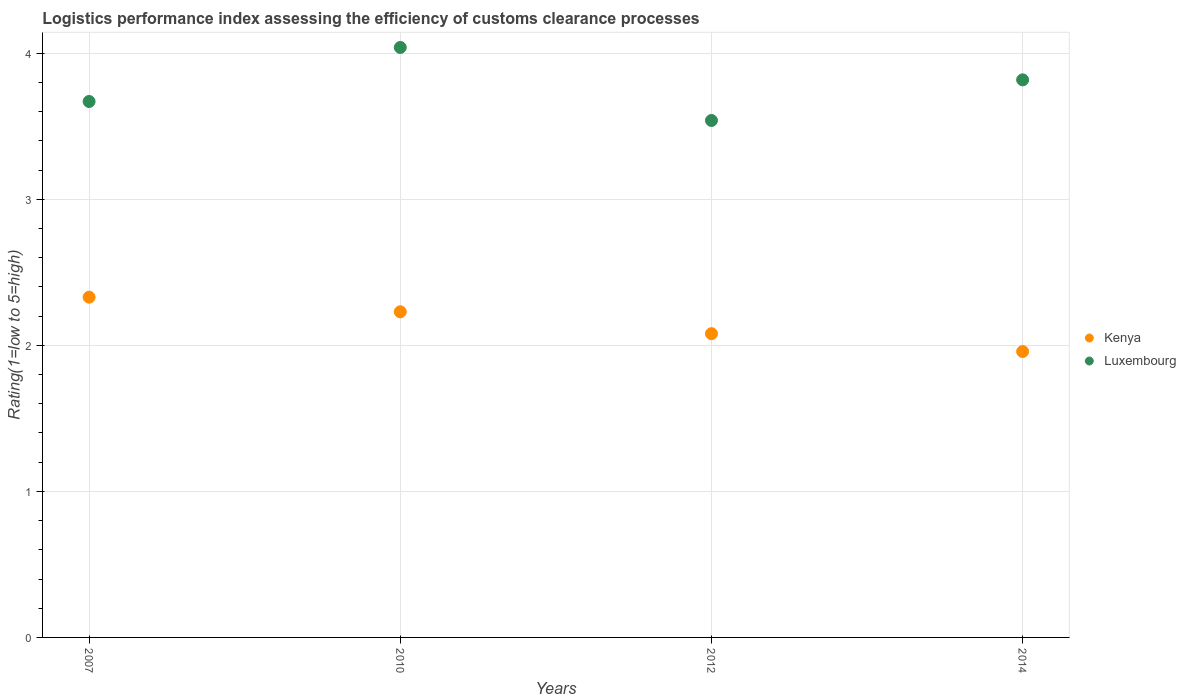What is the Logistic performance index in Kenya in 2007?
Provide a short and direct response. 2.33. Across all years, what is the maximum Logistic performance index in Luxembourg?
Keep it short and to the point. 4.04. Across all years, what is the minimum Logistic performance index in Luxembourg?
Provide a short and direct response. 3.54. In which year was the Logistic performance index in Luxembourg minimum?
Your response must be concise. 2012. What is the total Logistic performance index in Kenya in the graph?
Give a very brief answer. 8.6. What is the difference between the Logistic performance index in Kenya in 2012 and that in 2014?
Your answer should be very brief. 0.12. What is the difference between the Logistic performance index in Luxembourg in 2007 and the Logistic performance index in Kenya in 2010?
Offer a terse response. 1.44. What is the average Logistic performance index in Kenya per year?
Make the answer very short. 2.15. In the year 2012, what is the difference between the Logistic performance index in Kenya and Logistic performance index in Luxembourg?
Give a very brief answer. -1.46. What is the ratio of the Logistic performance index in Luxembourg in 2007 to that in 2014?
Give a very brief answer. 0.96. What is the difference between the highest and the second highest Logistic performance index in Luxembourg?
Keep it short and to the point. 0.22. What is the difference between the highest and the lowest Logistic performance index in Luxembourg?
Keep it short and to the point. 0.5. In how many years, is the Logistic performance index in Luxembourg greater than the average Logistic performance index in Luxembourg taken over all years?
Offer a very short reply. 2. Is the Logistic performance index in Luxembourg strictly less than the Logistic performance index in Kenya over the years?
Give a very brief answer. No. How many dotlines are there?
Offer a terse response. 2. How many years are there in the graph?
Your answer should be very brief. 4. What is the difference between two consecutive major ticks on the Y-axis?
Make the answer very short. 1. Are the values on the major ticks of Y-axis written in scientific E-notation?
Offer a terse response. No. Does the graph contain any zero values?
Offer a terse response. No. Does the graph contain grids?
Offer a very short reply. Yes. Where does the legend appear in the graph?
Provide a succinct answer. Center right. How many legend labels are there?
Ensure brevity in your answer.  2. What is the title of the graph?
Your answer should be very brief. Logistics performance index assessing the efficiency of customs clearance processes. What is the label or title of the X-axis?
Your answer should be compact. Years. What is the label or title of the Y-axis?
Offer a terse response. Rating(1=low to 5=high). What is the Rating(1=low to 5=high) of Kenya in 2007?
Offer a terse response. 2.33. What is the Rating(1=low to 5=high) of Luxembourg in 2007?
Provide a short and direct response. 3.67. What is the Rating(1=low to 5=high) in Kenya in 2010?
Provide a succinct answer. 2.23. What is the Rating(1=low to 5=high) in Luxembourg in 2010?
Make the answer very short. 4.04. What is the Rating(1=low to 5=high) in Kenya in 2012?
Provide a short and direct response. 2.08. What is the Rating(1=low to 5=high) of Luxembourg in 2012?
Keep it short and to the point. 3.54. What is the Rating(1=low to 5=high) in Kenya in 2014?
Make the answer very short. 1.96. What is the Rating(1=low to 5=high) of Luxembourg in 2014?
Give a very brief answer. 3.82. Across all years, what is the maximum Rating(1=low to 5=high) of Kenya?
Your response must be concise. 2.33. Across all years, what is the maximum Rating(1=low to 5=high) of Luxembourg?
Your response must be concise. 4.04. Across all years, what is the minimum Rating(1=low to 5=high) of Kenya?
Ensure brevity in your answer.  1.96. Across all years, what is the minimum Rating(1=low to 5=high) in Luxembourg?
Your answer should be very brief. 3.54. What is the total Rating(1=low to 5=high) in Kenya in the graph?
Your answer should be very brief. 8.6. What is the total Rating(1=low to 5=high) of Luxembourg in the graph?
Make the answer very short. 15.07. What is the difference between the Rating(1=low to 5=high) in Kenya in 2007 and that in 2010?
Give a very brief answer. 0.1. What is the difference between the Rating(1=low to 5=high) of Luxembourg in 2007 and that in 2010?
Offer a very short reply. -0.37. What is the difference between the Rating(1=low to 5=high) in Luxembourg in 2007 and that in 2012?
Provide a short and direct response. 0.13. What is the difference between the Rating(1=low to 5=high) of Kenya in 2007 and that in 2014?
Offer a very short reply. 0.37. What is the difference between the Rating(1=low to 5=high) of Luxembourg in 2007 and that in 2014?
Provide a short and direct response. -0.15. What is the difference between the Rating(1=low to 5=high) in Kenya in 2010 and that in 2012?
Keep it short and to the point. 0.15. What is the difference between the Rating(1=low to 5=high) in Luxembourg in 2010 and that in 2012?
Ensure brevity in your answer.  0.5. What is the difference between the Rating(1=low to 5=high) in Kenya in 2010 and that in 2014?
Keep it short and to the point. 0.27. What is the difference between the Rating(1=low to 5=high) in Luxembourg in 2010 and that in 2014?
Ensure brevity in your answer.  0.22. What is the difference between the Rating(1=low to 5=high) of Kenya in 2012 and that in 2014?
Your response must be concise. 0.12. What is the difference between the Rating(1=low to 5=high) of Luxembourg in 2012 and that in 2014?
Offer a very short reply. -0.28. What is the difference between the Rating(1=low to 5=high) of Kenya in 2007 and the Rating(1=low to 5=high) of Luxembourg in 2010?
Keep it short and to the point. -1.71. What is the difference between the Rating(1=low to 5=high) in Kenya in 2007 and the Rating(1=low to 5=high) in Luxembourg in 2012?
Your answer should be compact. -1.21. What is the difference between the Rating(1=low to 5=high) in Kenya in 2007 and the Rating(1=low to 5=high) in Luxembourg in 2014?
Provide a short and direct response. -1.49. What is the difference between the Rating(1=low to 5=high) of Kenya in 2010 and the Rating(1=low to 5=high) of Luxembourg in 2012?
Provide a succinct answer. -1.31. What is the difference between the Rating(1=low to 5=high) in Kenya in 2010 and the Rating(1=low to 5=high) in Luxembourg in 2014?
Offer a terse response. -1.59. What is the difference between the Rating(1=low to 5=high) in Kenya in 2012 and the Rating(1=low to 5=high) in Luxembourg in 2014?
Ensure brevity in your answer.  -1.74. What is the average Rating(1=low to 5=high) in Kenya per year?
Your answer should be compact. 2.15. What is the average Rating(1=low to 5=high) in Luxembourg per year?
Provide a succinct answer. 3.77. In the year 2007, what is the difference between the Rating(1=low to 5=high) in Kenya and Rating(1=low to 5=high) in Luxembourg?
Provide a short and direct response. -1.34. In the year 2010, what is the difference between the Rating(1=low to 5=high) in Kenya and Rating(1=low to 5=high) in Luxembourg?
Offer a terse response. -1.81. In the year 2012, what is the difference between the Rating(1=low to 5=high) in Kenya and Rating(1=low to 5=high) in Luxembourg?
Offer a very short reply. -1.46. In the year 2014, what is the difference between the Rating(1=low to 5=high) of Kenya and Rating(1=low to 5=high) of Luxembourg?
Your answer should be compact. -1.86. What is the ratio of the Rating(1=low to 5=high) in Kenya in 2007 to that in 2010?
Make the answer very short. 1.04. What is the ratio of the Rating(1=low to 5=high) of Luxembourg in 2007 to that in 2010?
Your answer should be compact. 0.91. What is the ratio of the Rating(1=low to 5=high) of Kenya in 2007 to that in 2012?
Keep it short and to the point. 1.12. What is the ratio of the Rating(1=low to 5=high) in Luxembourg in 2007 to that in 2012?
Provide a short and direct response. 1.04. What is the ratio of the Rating(1=low to 5=high) in Kenya in 2007 to that in 2014?
Offer a terse response. 1.19. What is the ratio of the Rating(1=low to 5=high) of Luxembourg in 2007 to that in 2014?
Your response must be concise. 0.96. What is the ratio of the Rating(1=low to 5=high) in Kenya in 2010 to that in 2012?
Ensure brevity in your answer.  1.07. What is the ratio of the Rating(1=low to 5=high) in Luxembourg in 2010 to that in 2012?
Your answer should be very brief. 1.14. What is the ratio of the Rating(1=low to 5=high) in Kenya in 2010 to that in 2014?
Offer a terse response. 1.14. What is the ratio of the Rating(1=low to 5=high) of Luxembourg in 2010 to that in 2014?
Your answer should be very brief. 1.06. What is the ratio of the Rating(1=low to 5=high) in Kenya in 2012 to that in 2014?
Provide a succinct answer. 1.06. What is the ratio of the Rating(1=low to 5=high) of Luxembourg in 2012 to that in 2014?
Offer a very short reply. 0.93. What is the difference between the highest and the second highest Rating(1=low to 5=high) in Kenya?
Give a very brief answer. 0.1. What is the difference between the highest and the second highest Rating(1=low to 5=high) in Luxembourg?
Provide a succinct answer. 0.22. What is the difference between the highest and the lowest Rating(1=low to 5=high) in Kenya?
Give a very brief answer. 0.37. 